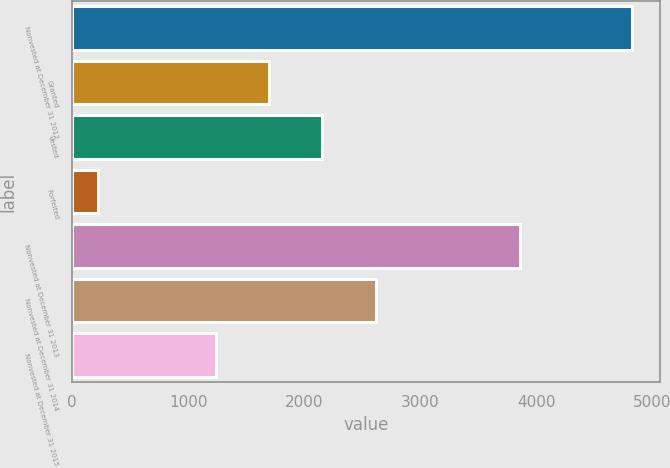<chart> <loc_0><loc_0><loc_500><loc_500><bar_chart><fcel>Nonvested at December 31 2012<fcel>Granted<fcel>Vested<fcel>Forfeited<fcel>Nonvested at December 31 2013<fcel>Nonvested at December 31 2014<fcel>Nonvested at December 31 2015<nl><fcel>4822<fcel>1695.6<fcel>2155.2<fcel>226<fcel>3859<fcel>2614.8<fcel>1236<nl></chart> 